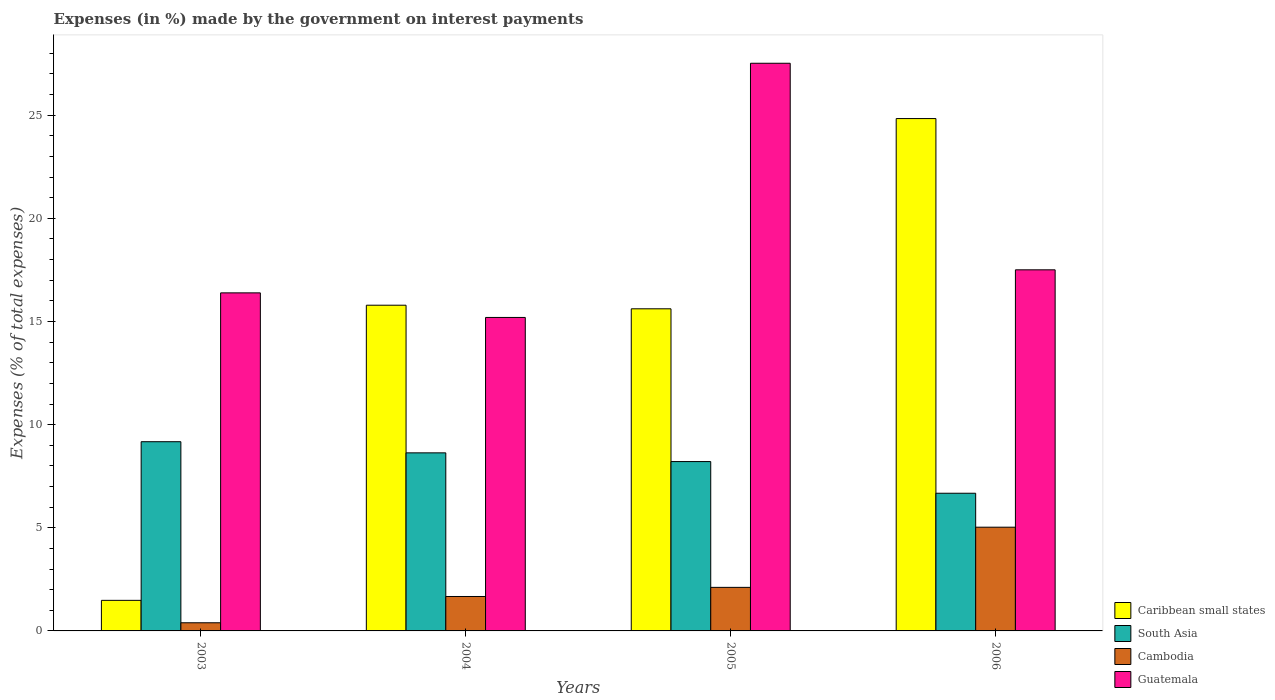Are the number of bars per tick equal to the number of legend labels?
Offer a terse response. Yes. Are the number of bars on each tick of the X-axis equal?
Make the answer very short. Yes. How many bars are there on the 4th tick from the right?
Ensure brevity in your answer.  4. In how many cases, is the number of bars for a given year not equal to the number of legend labels?
Give a very brief answer. 0. What is the percentage of expenses made by the government on interest payments in Caribbean small states in 2003?
Make the answer very short. 1.48. Across all years, what is the maximum percentage of expenses made by the government on interest payments in Cambodia?
Offer a terse response. 5.03. Across all years, what is the minimum percentage of expenses made by the government on interest payments in Caribbean small states?
Offer a very short reply. 1.48. What is the total percentage of expenses made by the government on interest payments in South Asia in the graph?
Provide a short and direct response. 32.69. What is the difference between the percentage of expenses made by the government on interest payments in Guatemala in 2004 and that in 2006?
Provide a succinct answer. -2.31. What is the difference between the percentage of expenses made by the government on interest payments in Caribbean small states in 2006 and the percentage of expenses made by the government on interest payments in South Asia in 2004?
Your answer should be compact. 16.21. What is the average percentage of expenses made by the government on interest payments in Guatemala per year?
Provide a succinct answer. 19.15. In the year 2005, what is the difference between the percentage of expenses made by the government on interest payments in Cambodia and percentage of expenses made by the government on interest payments in Guatemala?
Give a very brief answer. -25.41. In how many years, is the percentage of expenses made by the government on interest payments in South Asia greater than 6 %?
Provide a succinct answer. 4. What is the ratio of the percentage of expenses made by the government on interest payments in Caribbean small states in 2004 to that in 2006?
Provide a succinct answer. 0.64. Is the percentage of expenses made by the government on interest payments in Guatemala in 2004 less than that in 2005?
Offer a terse response. Yes. What is the difference between the highest and the second highest percentage of expenses made by the government on interest payments in Cambodia?
Provide a short and direct response. 2.92. What is the difference between the highest and the lowest percentage of expenses made by the government on interest payments in Caribbean small states?
Make the answer very short. 23.36. Is the sum of the percentage of expenses made by the government on interest payments in South Asia in 2005 and 2006 greater than the maximum percentage of expenses made by the government on interest payments in Caribbean small states across all years?
Your response must be concise. No. Is it the case that in every year, the sum of the percentage of expenses made by the government on interest payments in South Asia and percentage of expenses made by the government on interest payments in Caribbean small states is greater than the sum of percentage of expenses made by the government on interest payments in Guatemala and percentage of expenses made by the government on interest payments in Cambodia?
Your answer should be very brief. No. What does the 3rd bar from the left in 2005 represents?
Ensure brevity in your answer.  Cambodia. What does the 2nd bar from the right in 2005 represents?
Give a very brief answer. Cambodia. How many years are there in the graph?
Your response must be concise. 4. Does the graph contain any zero values?
Provide a succinct answer. No. Where does the legend appear in the graph?
Keep it short and to the point. Bottom right. What is the title of the graph?
Your response must be concise. Expenses (in %) made by the government on interest payments. What is the label or title of the X-axis?
Ensure brevity in your answer.  Years. What is the label or title of the Y-axis?
Your response must be concise. Expenses (% of total expenses). What is the Expenses (% of total expenses) of Caribbean small states in 2003?
Keep it short and to the point. 1.48. What is the Expenses (% of total expenses) in South Asia in 2003?
Your answer should be very brief. 9.17. What is the Expenses (% of total expenses) in Cambodia in 2003?
Your answer should be very brief. 0.39. What is the Expenses (% of total expenses) in Guatemala in 2003?
Provide a succinct answer. 16.39. What is the Expenses (% of total expenses) in Caribbean small states in 2004?
Your response must be concise. 15.79. What is the Expenses (% of total expenses) of South Asia in 2004?
Ensure brevity in your answer.  8.63. What is the Expenses (% of total expenses) in Cambodia in 2004?
Keep it short and to the point. 1.67. What is the Expenses (% of total expenses) of Guatemala in 2004?
Give a very brief answer. 15.2. What is the Expenses (% of total expenses) of Caribbean small states in 2005?
Give a very brief answer. 15.62. What is the Expenses (% of total expenses) of South Asia in 2005?
Make the answer very short. 8.21. What is the Expenses (% of total expenses) in Cambodia in 2005?
Provide a short and direct response. 2.11. What is the Expenses (% of total expenses) in Guatemala in 2005?
Offer a very short reply. 27.52. What is the Expenses (% of total expenses) in Caribbean small states in 2006?
Ensure brevity in your answer.  24.84. What is the Expenses (% of total expenses) of South Asia in 2006?
Your answer should be compact. 6.67. What is the Expenses (% of total expenses) of Cambodia in 2006?
Offer a terse response. 5.03. What is the Expenses (% of total expenses) of Guatemala in 2006?
Provide a short and direct response. 17.51. Across all years, what is the maximum Expenses (% of total expenses) in Caribbean small states?
Make the answer very short. 24.84. Across all years, what is the maximum Expenses (% of total expenses) of South Asia?
Provide a succinct answer. 9.17. Across all years, what is the maximum Expenses (% of total expenses) of Cambodia?
Make the answer very short. 5.03. Across all years, what is the maximum Expenses (% of total expenses) of Guatemala?
Your answer should be compact. 27.52. Across all years, what is the minimum Expenses (% of total expenses) of Caribbean small states?
Your response must be concise. 1.48. Across all years, what is the minimum Expenses (% of total expenses) of South Asia?
Your answer should be compact. 6.67. Across all years, what is the minimum Expenses (% of total expenses) in Cambodia?
Make the answer very short. 0.39. Across all years, what is the minimum Expenses (% of total expenses) of Guatemala?
Offer a terse response. 15.2. What is the total Expenses (% of total expenses) of Caribbean small states in the graph?
Offer a very short reply. 57.72. What is the total Expenses (% of total expenses) in South Asia in the graph?
Make the answer very short. 32.69. What is the total Expenses (% of total expenses) in Cambodia in the graph?
Provide a succinct answer. 9.2. What is the total Expenses (% of total expenses) in Guatemala in the graph?
Give a very brief answer. 76.61. What is the difference between the Expenses (% of total expenses) of Caribbean small states in 2003 and that in 2004?
Keep it short and to the point. -14.31. What is the difference between the Expenses (% of total expenses) in South Asia in 2003 and that in 2004?
Your answer should be compact. 0.54. What is the difference between the Expenses (% of total expenses) of Cambodia in 2003 and that in 2004?
Give a very brief answer. -1.27. What is the difference between the Expenses (% of total expenses) in Guatemala in 2003 and that in 2004?
Provide a succinct answer. 1.19. What is the difference between the Expenses (% of total expenses) in Caribbean small states in 2003 and that in 2005?
Provide a short and direct response. -14.13. What is the difference between the Expenses (% of total expenses) in South Asia in 2003 and that in 2005?
Your answer should be very brief. 0.96. What is the difference between the Expenses (% of total expenses) of Cambodia in 2003 and that in 2005?
Ensure brevity in your answer.  -1.72. What is the difference between the Expenses (% of total expenses) in Guatemala in 2003 and that in 2005?
Offer a terse response. -11.13. What is the difference between the Expenses (% of total expenses) in Caribbean small states in 2003 and that in 2006?
Offer a very short reply. -23.36. What is the difference between the Expenses (% of total expenses) of South Asia in 2003 and that in 2006?
Offer a terse response. 2.5. What is the difference between the Expenses (% of total expenses) of Cambodia in 2003 and that in 2006?
Offer a terse response. -4.63. What is the difference between the Expenses (% of total expenses) in Guatemala in 2003 and that in 2006?
Offer a terse response. -1.12. What is the difference between the Expenses (% of total expenses) in Caribbean small states in 2004 and that in 2005?
Provide a short and direct response. 0.17. What is the difference between the Expenses (% of total expenses) in South Asia in 2004 and that in 2005?
Offer a very short reply. 0.42. What is the difference between the Expenses (% of total expenses) in Cambodia in 2004 and that in 2005?
Give a very brief answer. -0.44. What is the difference between the Expenses (% of total expenses) in Guatemala in 2004 and that in 2005?
Provide a succinct answer. -12.32. What is the difference between the Expenses (% of total expenses) of Caribbean small states in 2004 and that in 2006?
Make the answer very short. -9.05. What is the difference between the Expenses (% of total expenses) of South Asia in 2004 and that in 2006?
Keep it short and to the point. 1.96. What is the difference between the Expenses (% of total expenses) of Cambodia in 2004 and that in 2006?
Give a very brief answer. -3.36. What is the difference between the Expenses (% of total expenses) in Guatemala in 2004 and that in 2006?
Make the answer very short. -2.31. What is the difference between the Expenses (% of total expenses) of Caribbean small states in 2005 and that in 2006?
Your answer should be very brief. -9.22. What is the difference between the Expenses (% of total expenses) in South Asia in 2005 and that in 2006?
Provide a succinct answer. 1.54. What is the difference between the Expenses (% of total expenses) in Cambodia in 2005 and that in 2006?
Keep it short and to the point. -2.92. What is the difference between the Expenses (% of total expenses) in Guatemala in 2005 and that in 2006?
Offer a terse response. 10.01. What is the difference between the Expenses (% of total expenses) in Caribbean small states in 2003 and the Expenses (% of total expenses) in South Asia in 2004?
Your response must be concise. -7.15. What is the difference between the Expenses (% of total expenses) in Caribbean small states in 2003 and the Expenses (% of total expenses) in Cambodia in 2004?
Give a very brief answer. -0.19. What is the difference between the Expenses (% of total expenses) in Caribbean small states in 2003 and the Expenses (% of total expenses) in Guatemala in 2004?
Offer a terse response. -13.72. What is the difference between the Expenses (% of total expenses) of South Asia in 2003 and the Expenses (% of total expenses) of Cambodia in 2004?
Provide a short and direct response. 7.5. What is the difference between the Expenses (% of total expenses) in South Asia in 2003 and the Expenses (% of total expenses) in Guatemala in 2004?
Give a very brief answer. -6.02. What is the difference between the Expenses (% of total expenses) in Cambodia in 2003 and the Expenses (% of total expenses) in Guatemala in 2004?
Make the answer very short. -14.8. What is the difference between the Expenses (% of total expenses) of Caribbean small states in 2003 and the Expenses (% of total expenses) of South Asia in 2005?
Your answer should be very brief. -6.73. What is the difference between the Expenses (% of total expenses) in Caribbean small states in 2003 and the Expenses (% of total expenses) in Cambodia in 2005?
Ensure brevity in your answer.  -0.63. What is the difference between the Expenses (% of total expenses) in Caribbean small states in 2003 and the Expenses (% of total expenses) in Guatemala in 2005?
Ensure brevity in your answer.  -26.04. What is the difference between the Expenses (% of total expenses) in South Asia in 2003 and the Expenses (% of total expenses) in Cambodia in 2005?
Your response must be concise. 7.06. What is the difference between the Expenses (% of total expenses) of South Asia in 2003 and the Expenses (% of total expenses) of Guatemala in 2005?
Provide a short and direct response. -18.35. What is the difference between the Expenses (% of total expenses) of Cambodia in 2003 and the Expenses (% of total expenses) of Guatemala in 2005?
Keep it short and to the point. -27.12. What is the difference between the Expenses (% of total expenses) of Caribbean small states in 2003 and the Expenses (% of total expenses) of South Asia in 2006?
Your response must be concise. -5.19. What is the difference between the Expenses (% of total expenses) of Caribbean small states in 2003 and the Expenses (% of total expenses) of Cambodia in 2006?
Your answer should be compact. -3.55. What is the difference between the Expenses (% of total expenses) in Caribbean small states in 2003 and the Expenses (% of total expenses) in Guatemala in 2006?
Ensure brevity in your answer.  -16.02. What is the difference between the Expenses (% of total expenses) in South Asia in 2003 and the Expenses (% of total expenses) in Cambodia in 2006?
Keep it short and to the point. 4.14. What is the difference between the Expenses (% of total expenses) in South Asia in 2003 and the Expenses (% of total expenses) in Guatemala in 2006?
Offer a terse response. -8.33. What is the difference between the Expenses (% of total expenses) in Cambodia in 2003 and the Expenses (% of total expenses) in Guatemala in 2006?
Offer a terse response. -17.11. What is the difference between the Expenses (% of total expenses) of Caribbean small states in 2004 and the Expenses (% of total expenses) of South Asia in 2005?
Your answer should be very brief. 7.58. What is the difference between the Expenses (% of total expenses) of Caribbean small states in 2004 and the Expenses (% of total expenses) of Cambodia in 2005?
Ensure brevity in your answer.  13.68. What is the difference between the Expenses (% of total expenses) of Caribbean small states in 2004 and the Expenses (% of total expenses) of Guatemala in 2005?
Provide a succinct answer. -11.73. What is the difference between the Expenses (% of total expenses) in South Asia in 2004 and the Expenses (% of total expenses) in Cambodia in 2005?
Provide a succinct answer. 6.52. What is the difference between the Expenses (% of total expenses) in South Asia in 2004 and the Expenses (% of total expenses) in Guatemala in 2005?
Your answer should be compact. -18.89. What is the difference between the Expenses (% of total expenses) in Cambodia in 2004 and the Expenses (% of total expenses) in Guatemala in 2005?
Your response must be concise. -25.85. What is the difference between the Expenses (% of total expenses) of Caribbean small states in 2004 and the Expenses (% of total expenses) of South Asia in 2006?
Offer a terse response. 9.12. What is the difference between the Expenses (% of total expenses) of Caribbean small states in 2004 and the Expenses (% of total expenses) of Cambodia in 2006?
Keep it short and to the point. 10.76. What is the difference between the Expenses (% of total expenses) in Caribbean small states in 2004 and the Expenses (% of total expenses) in Guatemala in 2006?
Make the answer very short. -1.72. What is the difference between the Expenses (% of total expenses) in South Asia in 2004 and the Expenses (% of total expenses) in Cambodia in 2006?
Make the answer very short. 3.6. What is the difference between the Expenses (% of total expenses) of South Asia in 2004 and the Expenses (% of total expenses) of Guatemala in 2006?
Make the answer very short. -8.87. What is the difference between the Expenses (% of total expenses) in Cambodia in 2004 and the Expenses (% of total expenses) in Guatemala in 2006?
Your answer should be compact. -15.84. What is the difference between the Expenses (% of total expenses) in Caribbean small states in 2005 and the Expenses (% of total expenses) in South Asia in 2006?
Offer a terse response. 8.94. What is the difference between the Expenses (% of total expenses) in Caribbean small states in 2005 and the Expenses (% of total expenses) in Cambodia in 2006?
Ensure brevity in your answer.  10.59. What is the difference between the Expenses (% of total expenses) of Caribbean small states in 2005 and the Expenses (% of total expenses) of Guatemala in 2006?
Provide a succinct answer. -1.89. What is the difference between the Expenses (% of total expenses) in South Asia in 2005 and the Expenses (% of total expenses) in Cambodia in 2006?
Your answer should be compact. 3.18. What is the difference between the Expenses (% of total expenses) in South Asia in 2005 and the Expenses (% of total expenses) in Guatemala in 2006?
Offer a very short reply. -9.3. What is the difference between the Expenses (% of total expenses) of Cambodia in 2005 and the Expenses (% of total expenses) of Guatemala in 2006?
Your answer should be compact. -15.39. What is the average Expenses (% of total expenses) in Caribbean small states per year?
Offer a terse response. 14.43. What is the average Expenses (% of total expenses) in South Asia per year?
Give a very brief answer. 8.17. What is the average Expenses (% of total expenses) in Cambodia per year?
Make the answer very short. 2.3. What is the average Expenses (% of total expenses) of Guatemala per year?
Your answer should be very brief. 19.15. In the year 2003, what is the difference between the Expenses (% of total expenses) in Caribbean small states and Expenses (% of total expenses) in South Asia?
Your response must be concise. -7.69. In the year 2003, what is the difference between the Expenses (% of total expenses) of Caribbean small states and Expenses (% of total expenses) of Cambodia?
Your answer should be compact. 1.09. In the year 2003, what is the difference between the Expenses (% of total expenses) in Caribbean small states and Expenses (% of total expenses) in Guatemala?
Your answer should be very brief. -14.91. In the year 2003, what is the difference between the Expenses (% of total expenses) of South Asia and Expenses (% of total expenses) of Cambodia?
Keep it short and to the point. 8.78. In the year 2003, what is the difference between the Expenses (% of total expenses) in South Asia and Expenses (% of total expenses) in Guatemala?
Give a very brief answer. -7.22. In the year 2003, what is the difference between the Expenses (% of total expenses) of Cambodia and Expenses (% of total expenses) of Guatemala?
Give a very brief answer. -15.99. In the year 2004, what is the difference between the Expenses (% of total expenses) in Caribbean small states and Expenses (% of total expenses) in South Asia?
Provide a short and direct response. 7.16. In the year 2004, what is the difference between the Expenses (% of total expenses) in Caribbean small states and Expenses (% of total expenses) in Cambodia?
Provide a short and direct response. 14.12. In the year 2004, what is the difference between the Expenses (% of total expenses) in Caribbean small states and Expenses (% of total expenses) in Guatemala?
Your answer should be very brief. 0.59. In the year 2004, what is the difference between the Expenses (% of total expenses) of South Asia and Expenses (% of total expenses) of Cambodia?
Offer a terse response. 6.96. In the year 2004, what is the difference between the Expenses (% of total expenses) in South Asia and Expenses (% of total expenses) in Guatemala?
Offer a very short reply. -6.56. In the year 2004, what is the difference between the Expenses (% of total expenses) in Cambodia and Expenses (% of total expenses) in Guatemala?
Ensure brevity in your answer.  -13.53. In the year 2005, what is the difference between the Expenses (% of total expenses) of Caribbean small states and Expenses (% of total expenses) of South Asia?
Make the answer very short. 7.41. In the year 2005, what is the difference between the Expenses (% of total expenses) of Caribbean small states and Expenses (% of total expenses) of Cambodia?
Give a very brief answer. 13.5. In the year 2005, what is the difference between the Expenses (% of total expenses) of Caribbean small states and Expenses (% of total expenses) of Guatemala?
Provide a succinct answer. -11.9. In the year 2005, what is the difference between the Expenses (% of total expenses) in South Asia and Expenses (% of total expenses) in Cambodia?
Your response must be concise. 6.1. In the year 2005, what is the difference between the Expenses (% of total expenses) of South Asia and Expenses (% of total expenses) of Guatemala?
Offer a terse response. -19.31. In the year 2005, what is the difference between the Expenses (% of total expenses) of Cambodia and Expenses (% of total expenses) of Guatemala?
Your answer should be compact. -25.41. In the year 2006, what is the difference between the Expenses (% of total expenses) of Caribbean small states and Expenses (% of total expenses) of South Asia?
Your response must be concise. 18.16. In the year 2006, what is the difference between the Expenses (% of total expenses) in Caribbean small states and Expenses (% of total expenses) in Cambodia?
Your response must be concise. 19.81. In the year 2006, what is the difference between the Expenses (% of total expenses) of Caribbean small states and Expenses (% of total expenses) of Guatemala?
Ensure brevity in your answer.  7.33. In the year 2006, what is the difference between the Expenses (% of total expenses) of South Asia and Expenses (% of total expenses) of Cambodia?
Keep it short and to the point. 1.65. In the year 2006, what is the difference between the Expenses (% of total expenses) of South Asia and Expenses (% of total expenses) of Guatemala?
Make the answer very short. -10.83. In the year 2006, what is the difference between the Expenses (% of total expenses) in Cambodia and Expenses (% of total expenses) in Guatemala?
Offer a very short reply. -12.48. What is the ratio of the Expenses (% of total expenses) of Caribbean small states in 2003 to that in 2004?
Provide a short and direct response. 0.09. What is the ratio of the Expenses (% of total expenses) in South Asia in 2003 to that in 2004?
Your answer should be very brief. 1.06. What is the ratio of the Expenses (% of total expenses) in Cambodia in 2003 to that in 2004?
Your answer should be very brief. 0.24. What is the ratio of the Expenses (% of total expenses) in Guatemala in 2003 to that in 2004?
Make the answer very short. 1.08. What is the ratio of the Expenses (% of total expenses) of Caribbean small states in 2003 to that in 2005?
Your response must be concise. 0.09. What is the ratio of the Expenses (% of total expenses) of South Asia in 2003 to that in 2005?
Keep it short and to the point. 1.12. What is the ratio of the Expenses (% of total expenses) in Cambodia in 2003 to that in 2005?
Keep it short and to the point. 0.19. What is the ratio of the Expenses (% of total expenses) of Guatemala in 2003 to that in 2005?
Your answer should be very brief. 0.6. What is the ratio of the Expenses (% of total expenses) in Caribbean small states in 2003 to that in 2006?
Keep it short and to the point. 0.06. What is the ratio of the Expenses (% of total expenses) of South Asia in 2003 to that in 2006?
Give a very brief answer. 1.37. What is the ratio of the Expenses (% of total expenses) in Cambodia in 2003 to that in 2006?
Your response must be concise. 0.08. What is the ratio of the Expenses (% of total expenses) of Guatemala in 2003 to that in 2006?
Give a very brief answer. 0.94. What is the ratio of the Expenses (% of total expenses) of Caribbean small states in 2004 to that in 2005?
Provide a succinct answer. 1.01. What is the ratio of the Expenses (% of total expenses) in South Asia in 2004 to that in 2005?
Ensure brevity in your answer.  1.05. What is the ratio of the Expenses (% of total expenses) of Cambodia in 2004 to that in 2005?
Provide a succinct answer. 0.79. What is the ratio of the Expenses (% of total expenses) in Guatemala in 2004 to that in 2005?
Your response must be concise. 0.55. What is the ratio of the Expenses (% of total expenses) in Caribbean small states in 2004 to that in 2006?
Make the answer very short. 0.64. What is the ratio of the Expenses (% of total expenses) of South Asia in 2004 to that in 2006?
Keep it short and to the point. 1.29. What is the ratio of the Expenses (% of total expenses) of Cambodia in 2004 to that in 2006?
Ensure brevity in your answer.  0.33. What is the ratio of the Expenses (% of total expenses) of Guatemala in 2004 to that in 2006?
Ensure brevity in your answer.  0.87. What is the ratio of the Expenses (% of total expenses) of Caribbean small states in 2005 to that in 2006?
Offer a terse response. 0.63. What is the ratio of the Expenses (% of total expenses) in South Asia in 2005 to that in 2006?
Your response must be concise. 1.23. What is the ratio of the Expenses (% of total expenses) in Cambodia in 2005 to that in 2006?
Your answer should be compact. 0.42. What is the ratio of the Expenses (% of total expenses) of Guatemala in 2005 to that in 2006?
Make the answer very short. 1.57. What is the difference between the highest and the second highest Expenses (% of total expenses) in Caribbean small states?
Give a very brief answer. 9.05. What is the difference between the highest and the second highest Expenses (% of total expenses) of South Asia?
Provide a succinct answer. 0.54. What is the difference between the highest and the second highest Expenses (% of total expenses) of Cambodia?
Your answer should be compact. 2.92. What is the difference between the highest and the second highest Expenses (% of total expenses) of Guatemala?
Provide a short and direct response. 10.01. What is the difference between the highest and the lowest Expenses (% of total expenses) of Caribbean small states?
Your answer should be very brief. 23.36. What is the difference between the highest and the lowest Expenses (% of total expenses) of South Asia?
Offer a very short reply. 2.5. What is the difference between the highest and the lowest Expenses (% of total expenses) of Cambodia?
Ensure brevity in your answer.  4.63. What is the difference between the highest and the lowest Expenses (% of total expenses) in Guatemala?
Ensure brevity in your answer.  12.32. 